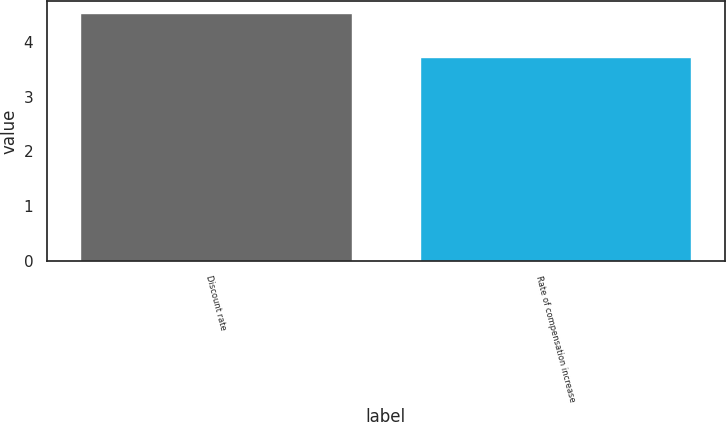<chart> <loc_0><loc_0><loc_500><loc_500><bar_chart><fcel>Discount rate<fcel>Rate of compensation increase<nl><fcel>4.52<fcel>3.73<nl></chart> 